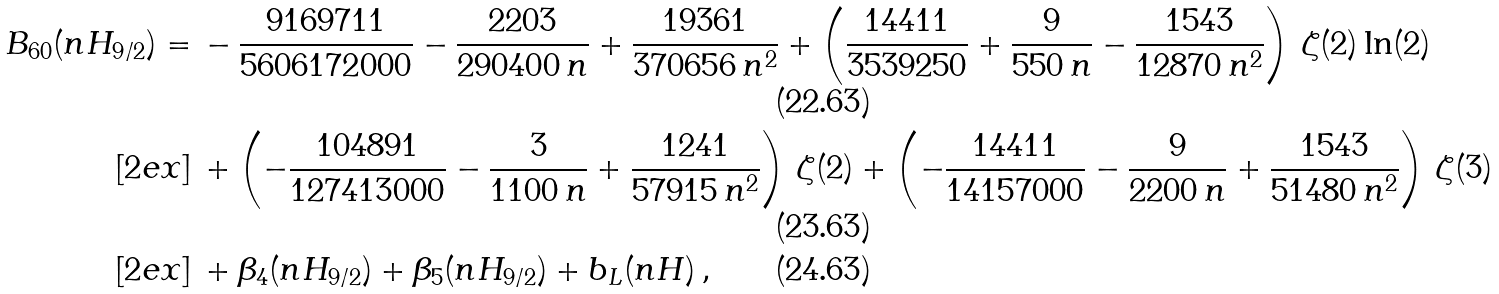Convert formula to latex. <formula><loc_0><loc_0><loc_500><loc_500>B _ { 6 0 } ( n H _ { 9 / 2 } ) = & \, - \frac { 9 1 6 9 7 1 1 } { 5 6 0 6 1 7 2 0 0 0 } - \frac { 2 2 0 3 } { 2 9 0 4 0 0 \, n } + \frac { 1 9 3 6 1 } { 3 7 0 6 5 6 \, n ^ { 2 } } + \left ( \frac { 1 4 4 1 1 } { 3 5 3 9 2 5 0 } + \frac { 9 } { 5 5 0 \, n } - \frac { 1 5 4 3 } { 1 2 8 7 0 \, n ^ { 2 } } \right ) \, \zeta ( 2 ) \ln ( 2 ) \\ [ 2 e x ] & \, + \left ( - \frac { 1 0 4 8 9 1 } { 1 2 7 4 1 3 0 0 0 } - \frac { 3 } { 1 1 0 0 \, n } + \frac { 1 2 4 1 } { 5 7 9 1 5 \, n ^ { 2 } } \right ) \, \zeta ( 2 ) + \left ( - \frac { 1 4 4 1 1 } { 1 4 1 5 7 0 0 0 } - \frac { 9 } { 2 2 0 0 \, n } + \frac { 1 5 4 3 } { 5 1 4 8 0 \, n ^ { 2 } } \right ) \, \zeta ( 3 ) \\ [ 2 e x ] & \, + \beta _ { 4 } ( n H _ { 9 / 2 } ) + \beta _ { 5 } ( n H _ { 9 / 2 } ) + b _ { L } ( n H ) \, ,</formula> 